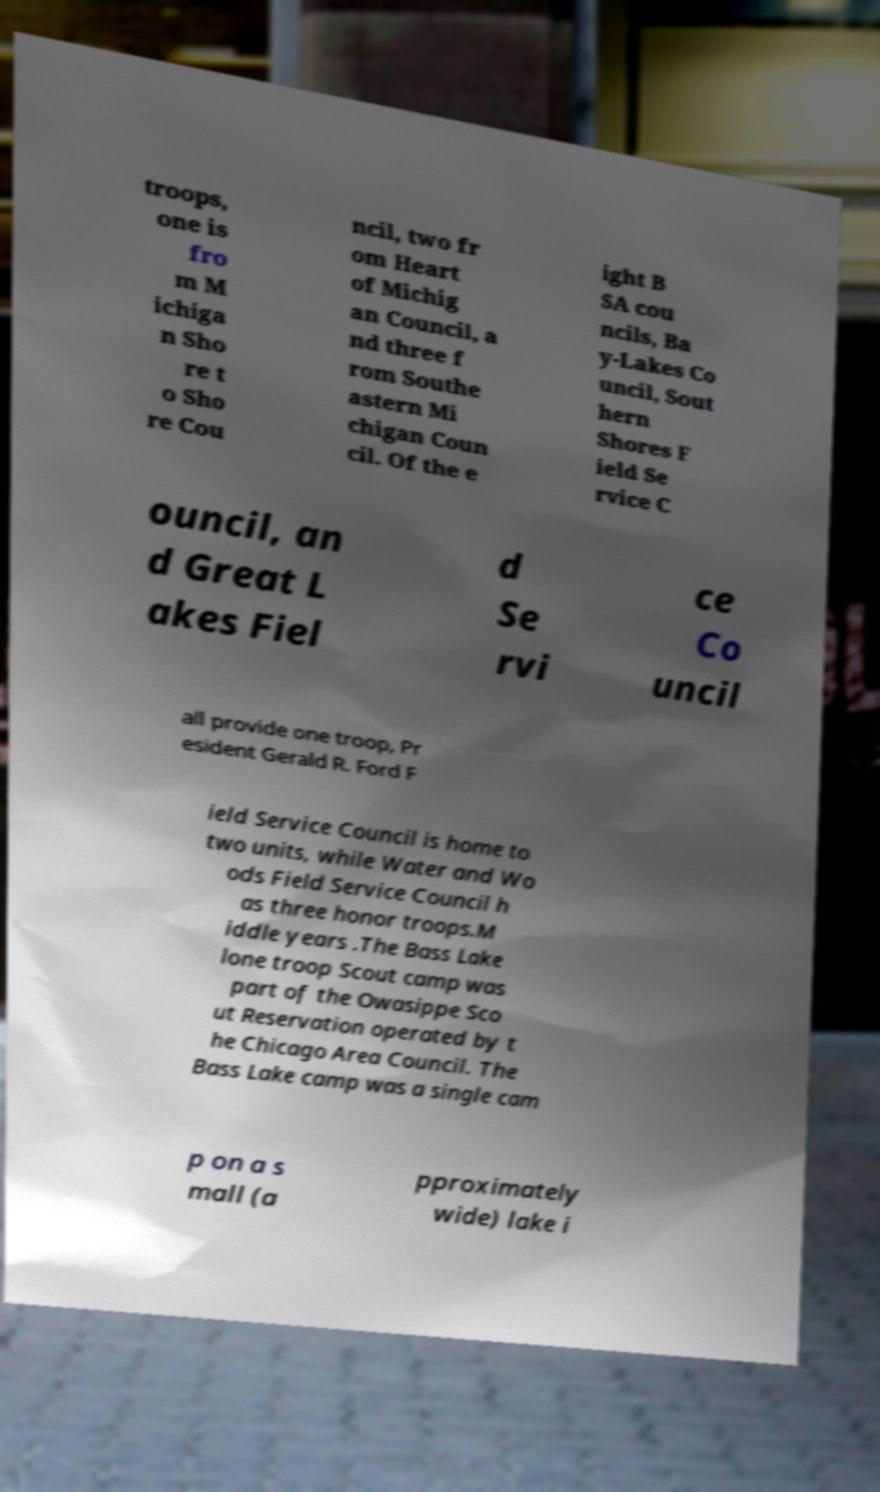Please identify and transcribe the text found in this image. troops, one is fro m M ichiga n Sho re t o Sho re Cou ncil, two fr om Heart of Michig an Council, a nd three f rom Southe astern Mi chigan Coun cil. Of the e ight B SA cou ncils, Ba y-Lakes Co uncil, Sout hern Shores F ield Se rvice C ouncil, an d Great L akes Fiel d Se rvi ce Co uncil all provide one troop, Pr esident Gerald R. Ford F ield Service Council is home to two units, while Water and Wo ods Field Service Council h as three honor troops.M iddle years .The Bass Lake lone troop Scout camp was part of the Owasippe Sco ut Reservation operated by t he Chicago Area Council. The Bass Lake camp was a single cam p on a s mall (a pproximately wide) lake i 